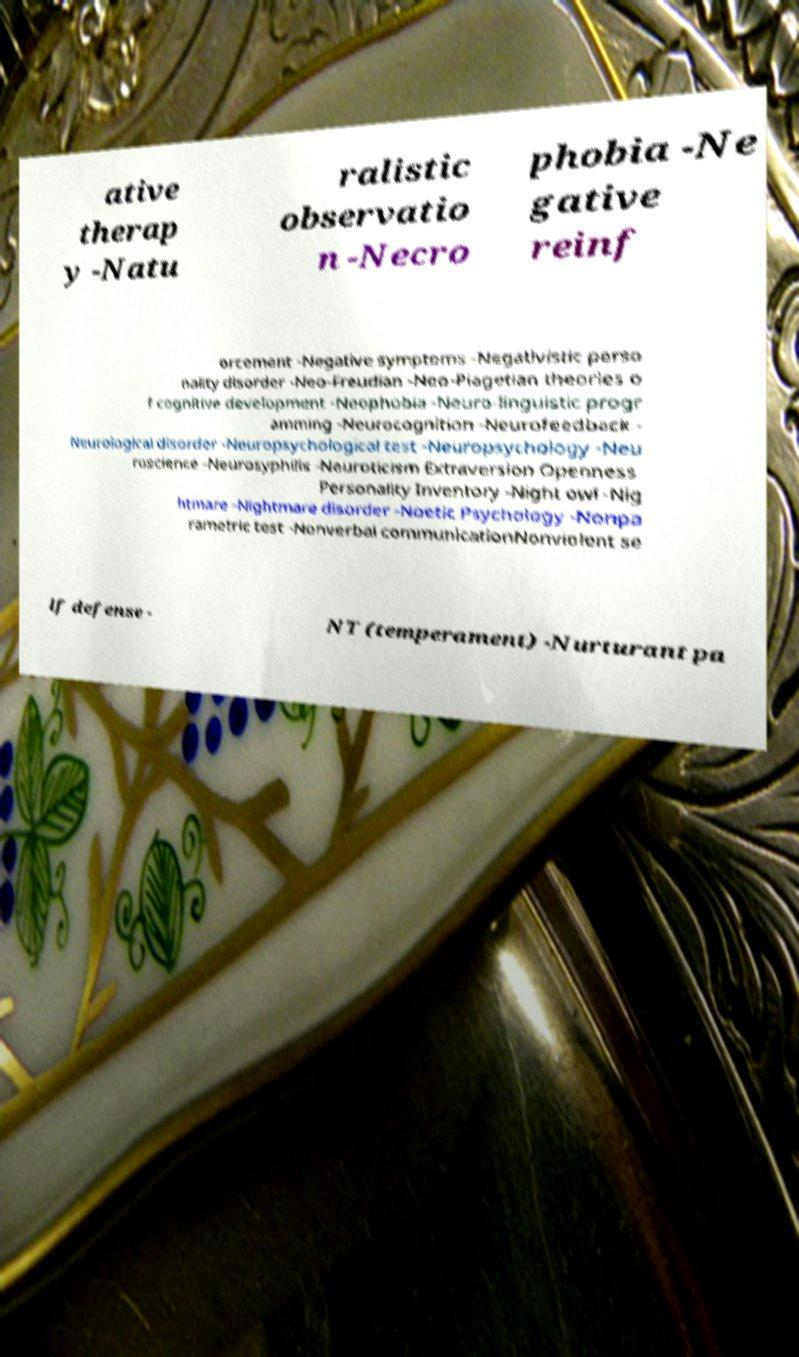Could you extract and type out the text from this image? ative therap y -Natu ralistic observatio n -Necro phobia -Ne gative reinf orcement -Negative symptoms -Negativistic perso nality disorder -Neo-Freudian -Neo-Piagetian theories o f cognitive development -Neophobia -Neuro-linguistic progr amming -Neurocognition -Neurofeedback - Neurological disorder -Neuropsychological test -Neuropsychology -Neu roscience -Neurosyphilis -Neuroticism Extraversion Openness Personality Inventory -Night owl -Nig htmare -Nightmare disorder -Noetic Psychology -Nonpa rametric test -Nonverbal communicationNonviolent se lf defense - NT (temperament) -Nurturant pa 